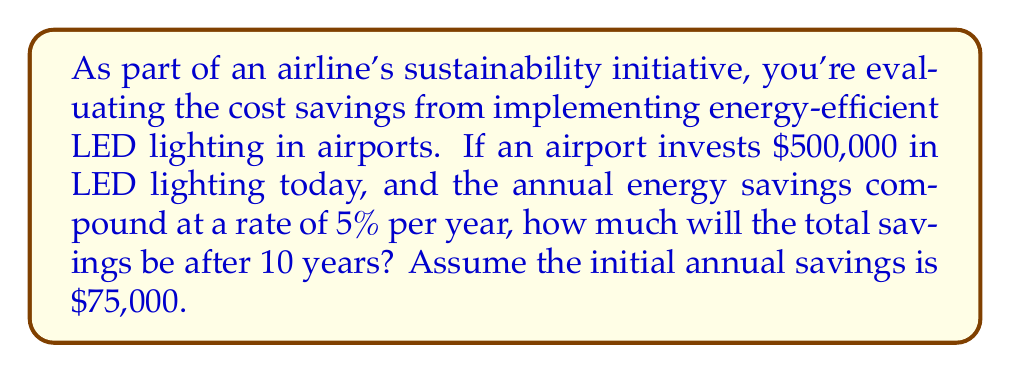Give your solution to this math problem. To solve this problem, we'll use the compound interest formula:

$$A = P(1 + r)^n$$

Where:
$A$ = final amount
$P$ = principal (initial investment)
$r$ = annual interest rate (in decimal form)
$n$ = number of years

In this case:
$P = 75,000$ (initial annual savings)
$r = 0.05$ (5% annual compound rate)
$n = 10$ years

Let's calculate:

$$A = 75,000(1 + 0.05)^{10}$$
$$A = 75,000(1.05)^{10}$$
$$A = 75,000(1.6288946)$$
$$A = 122,167.10$$

This means the annual savings in year 10 will be $122,167.10.

To find the total savings over 10 years, we need to sum up all the annual savings. We can use the formula for the sum of a geometric series:

$$S_n = \frac{a(1-r^n)}{1-r}$$

Where:
$S_n$ = sum of the series
$a$ = first term (initial annual savings)
$r$ = common ratio (1 + interest rate)
$n$ = number of terms

$$S_{10} = \frac{75,000(1-(1.05)^{10})}{1-1.05}$$
$$S_{10} = \frac{75,000(1-1.6288946)}{-0.05}$$
$$S_{10} = \frac{75,000(-0.6288946)}{-0.05}$$
$$S_{10} = 943,341.90$$

Therefore, the total savings over 10 years will be $943,341.90.

To get the net savings, we subtract the initial investment:

$$Net Savings = 943,341.90 - 500,000 = 443,341.90$$
Answer: $443,341.90 